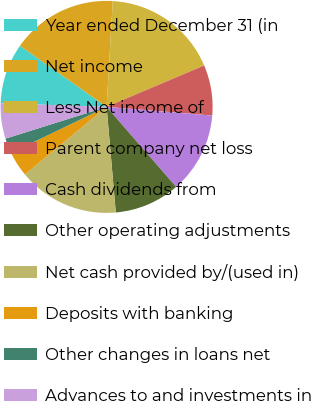Convert chart to OTSL. <chart><loc_0><loc_0><loc_500><loc_500><pie_chart><fcel>Year ended December 31 (in<fcel>Net income<fcel>Less Net income of<fcel>Parent company net loss<fcel>Cash dividends from<fcel>Other operating adjustments<fcel>Net cash provided by/(used in)<fcel>Deposits with banking<fcel>Other changes in loans net<fcel>Advances to and investments in<nl><fcel>9.23%<fcel>16.15%<fcel>17.69%<fcel>7.69%<fcel>12.31%<fcel>10.0%<fcel>15.38%<fcel>3.85%<fcel>2.31%<fcel>5.39%<nl></chart> 